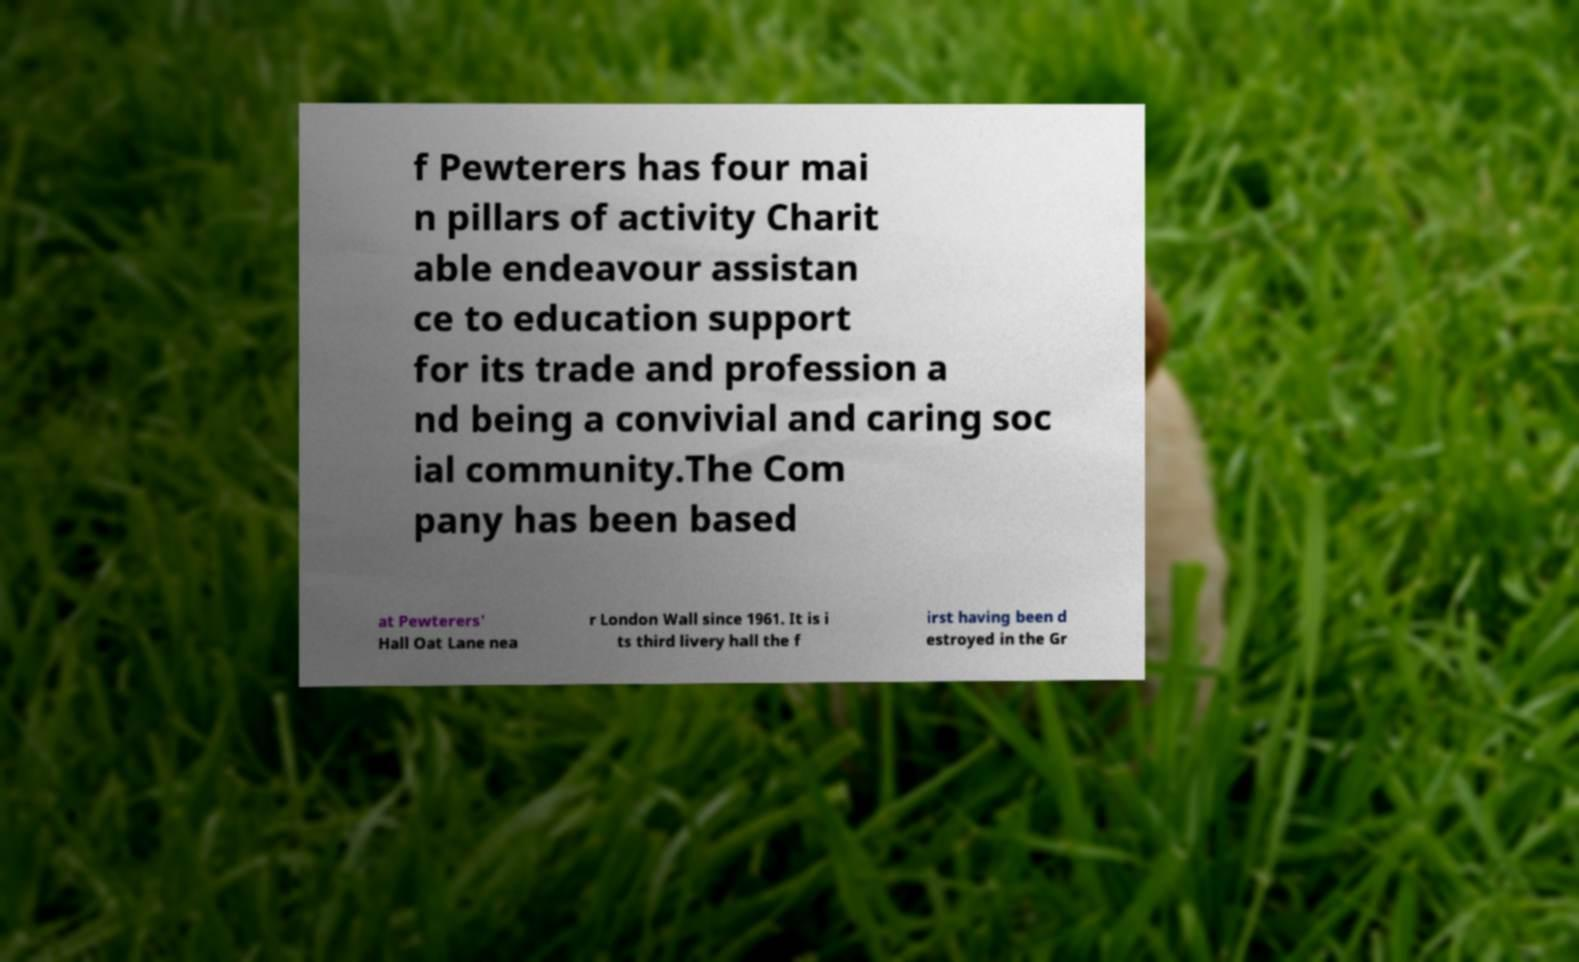Please identify and transcribe the text found in this image. f Pewterers has four mai n pillars of activity Charit able endeavour assistan ce to education support for its trade and profession a nd being a convivial and caring soc ial community.The Com pany has been based at Pewterers' Hall Oat Lane nea r London Wall since 1961. It is i ts third livery hall the f irst having been d estroyed in the Gr 